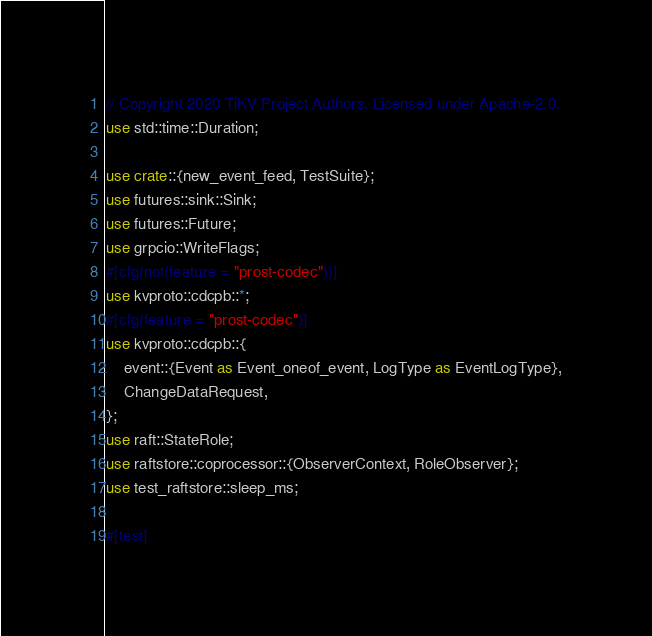<code> <loc_0><loc_0><loc_500><loc_500><_Rust_>// Copyright 2020 TiKV Project Authors. Licensed under Apache-2.0.
use std::time::Duration;

use crate::{new_event_feed, TestSuite};
use futures::sink::Sink;
use futures::Future;
use grpcio::WriteFlags;
#[cfg(not(feature = "prost-codec"))]
use kvproto::cdcpb::*;
#[cfg(feature = "prost-codec")]
use kvproto::cdcpb::{
    event::{Event as Event_oneof_event, LogType as EventLogType},
    ChangeDataRequest,
};
use raft::StateRole;
use raftstore::coprocessor::{ObserverContext, RoleObserver};
use test_raftstore::sleep_ms;

#[test]</code> 